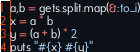<code> <loc_0><loc_0><loc_500><loc_500><_Ruby_>a,b = gets.split.map(&:to_i)
x = a * b
y = (a + b) * 2
puts "#{x} #{y}"</code> 